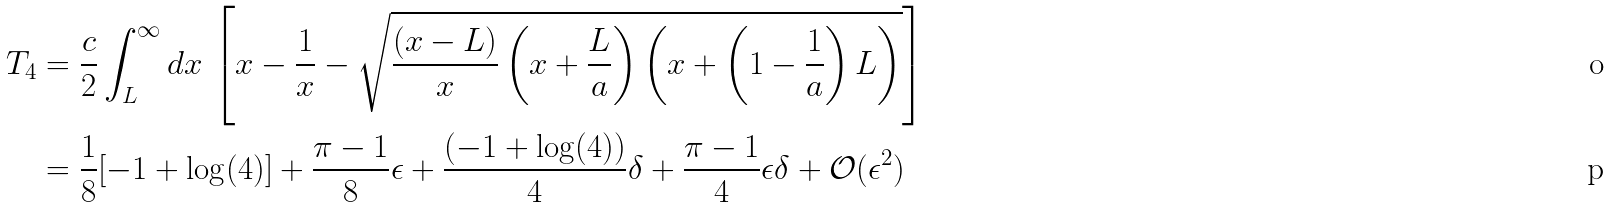Convert formula to latex. <formula><loc_0><loc_0><loc_500><loc_500>T _ { 4 } & = \frac { c } { 2 } \int _ { L } ^ { \infty } d x \, \left [ x - \frac { 1 } { x } - \sqrt { \frac { ( x - L ) } { x } \left ( x + \frac { L } { a } \right ) \left ( x + \left ( 1 - \frac { 1 } { a } \right ) L \right ) } \right ] \\ & = \frac { 1 } { 8 } [ - 1 + \log ( 4 ) ] + \frac { \pi - 1 } { 8 } \epsilon + \frac { ( - 1 + \log ( 4 ) ) } { 4 } \delta + \frac { \pi - 1 } { 4 } \epsilon \delta + \mathcal { O } ( \epsilon ^ { 2 } )</formula> 